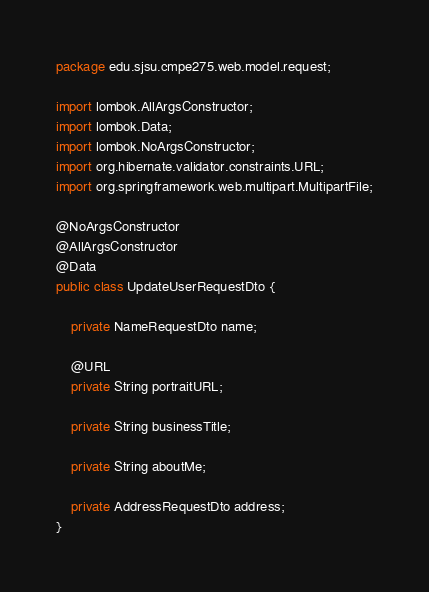Convert code to text. <code><loc_0><loc_0><loc_500><loc_500><_Java_>package edu.sjsu.cmpe275.web.model.request;

import lombok.AllArgsConstructor;
import lombok.Data;
import lombok.NoArgsConstructor;
import org.hibernate.validator.constraints.URL;
import org.springframework.web.multipart.MultipartFile;

@NoArgsConstructor
@AllArgsConstructor
@Data
public class UpdateUserRequestDto {

    private NameRequestDto name;

    @URL
    private String portraitURL;

    private String businessTitle;

    private String aboutMe;

    private AddressRequestDto address;
}
</code> 